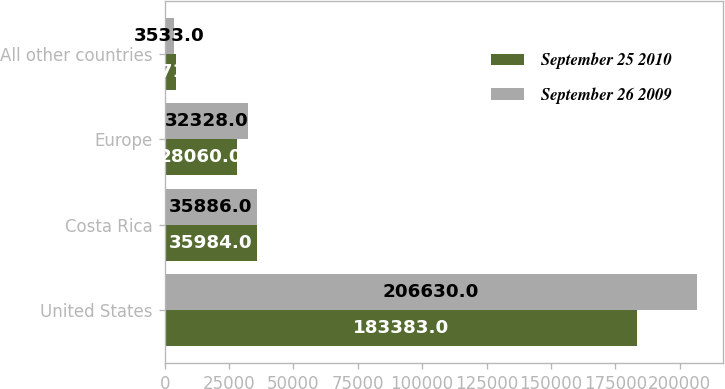<chart> <loc_0><loc_0><loc_500><loc_500><stacked_bar_chart><ecel><fcel>United States<fcel>Costa Rica<fcel>Europe<fcel>All other countries<nl><fcel>September 25 2010<fcel>183383<fcel>35984<fcel>28060<fcel>4271<nl><fcel>September 26 2009<fcel>206630<fcel>35886<fcel>32328<fcel>3533<nl></chart> 